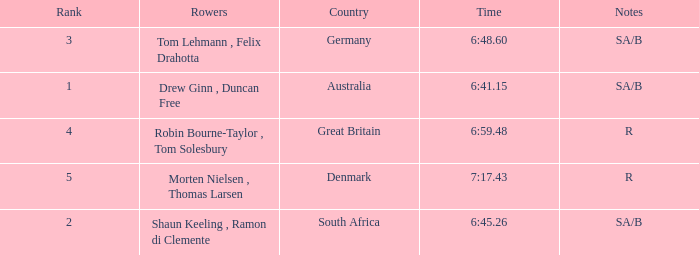What was the time for the rowers representing great britain? 6:59.48. 